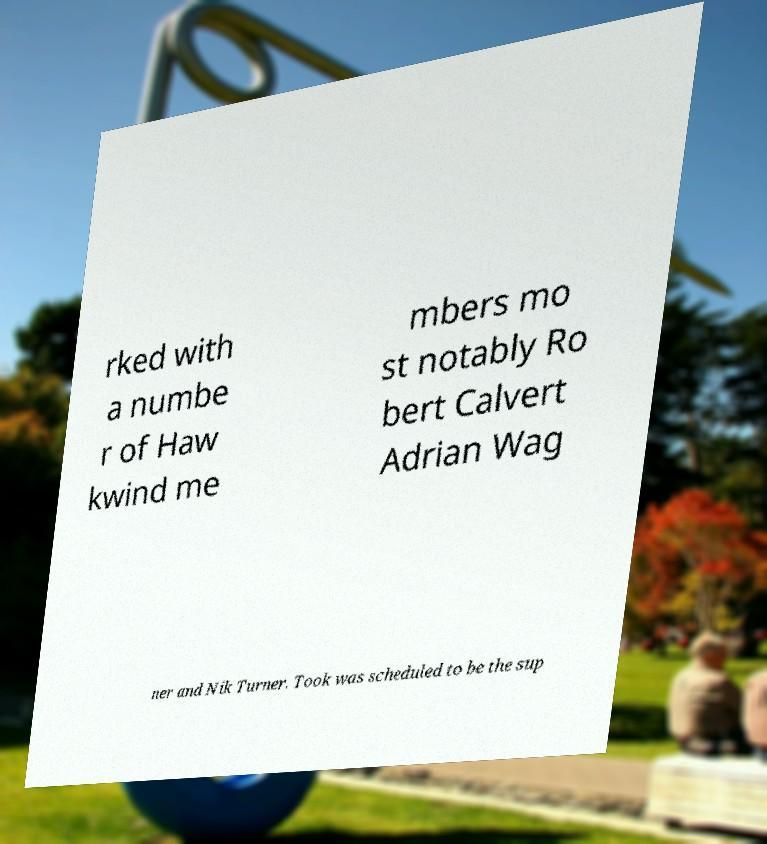For documentation purposes, I need the text within this image transcribed. Could you provide that? rked with a numbe r of Haw kwind me mbers mo st notably Ro bert Calvert Adrian Wag ner and Nik Turner. Took was scheduled to be the sup 